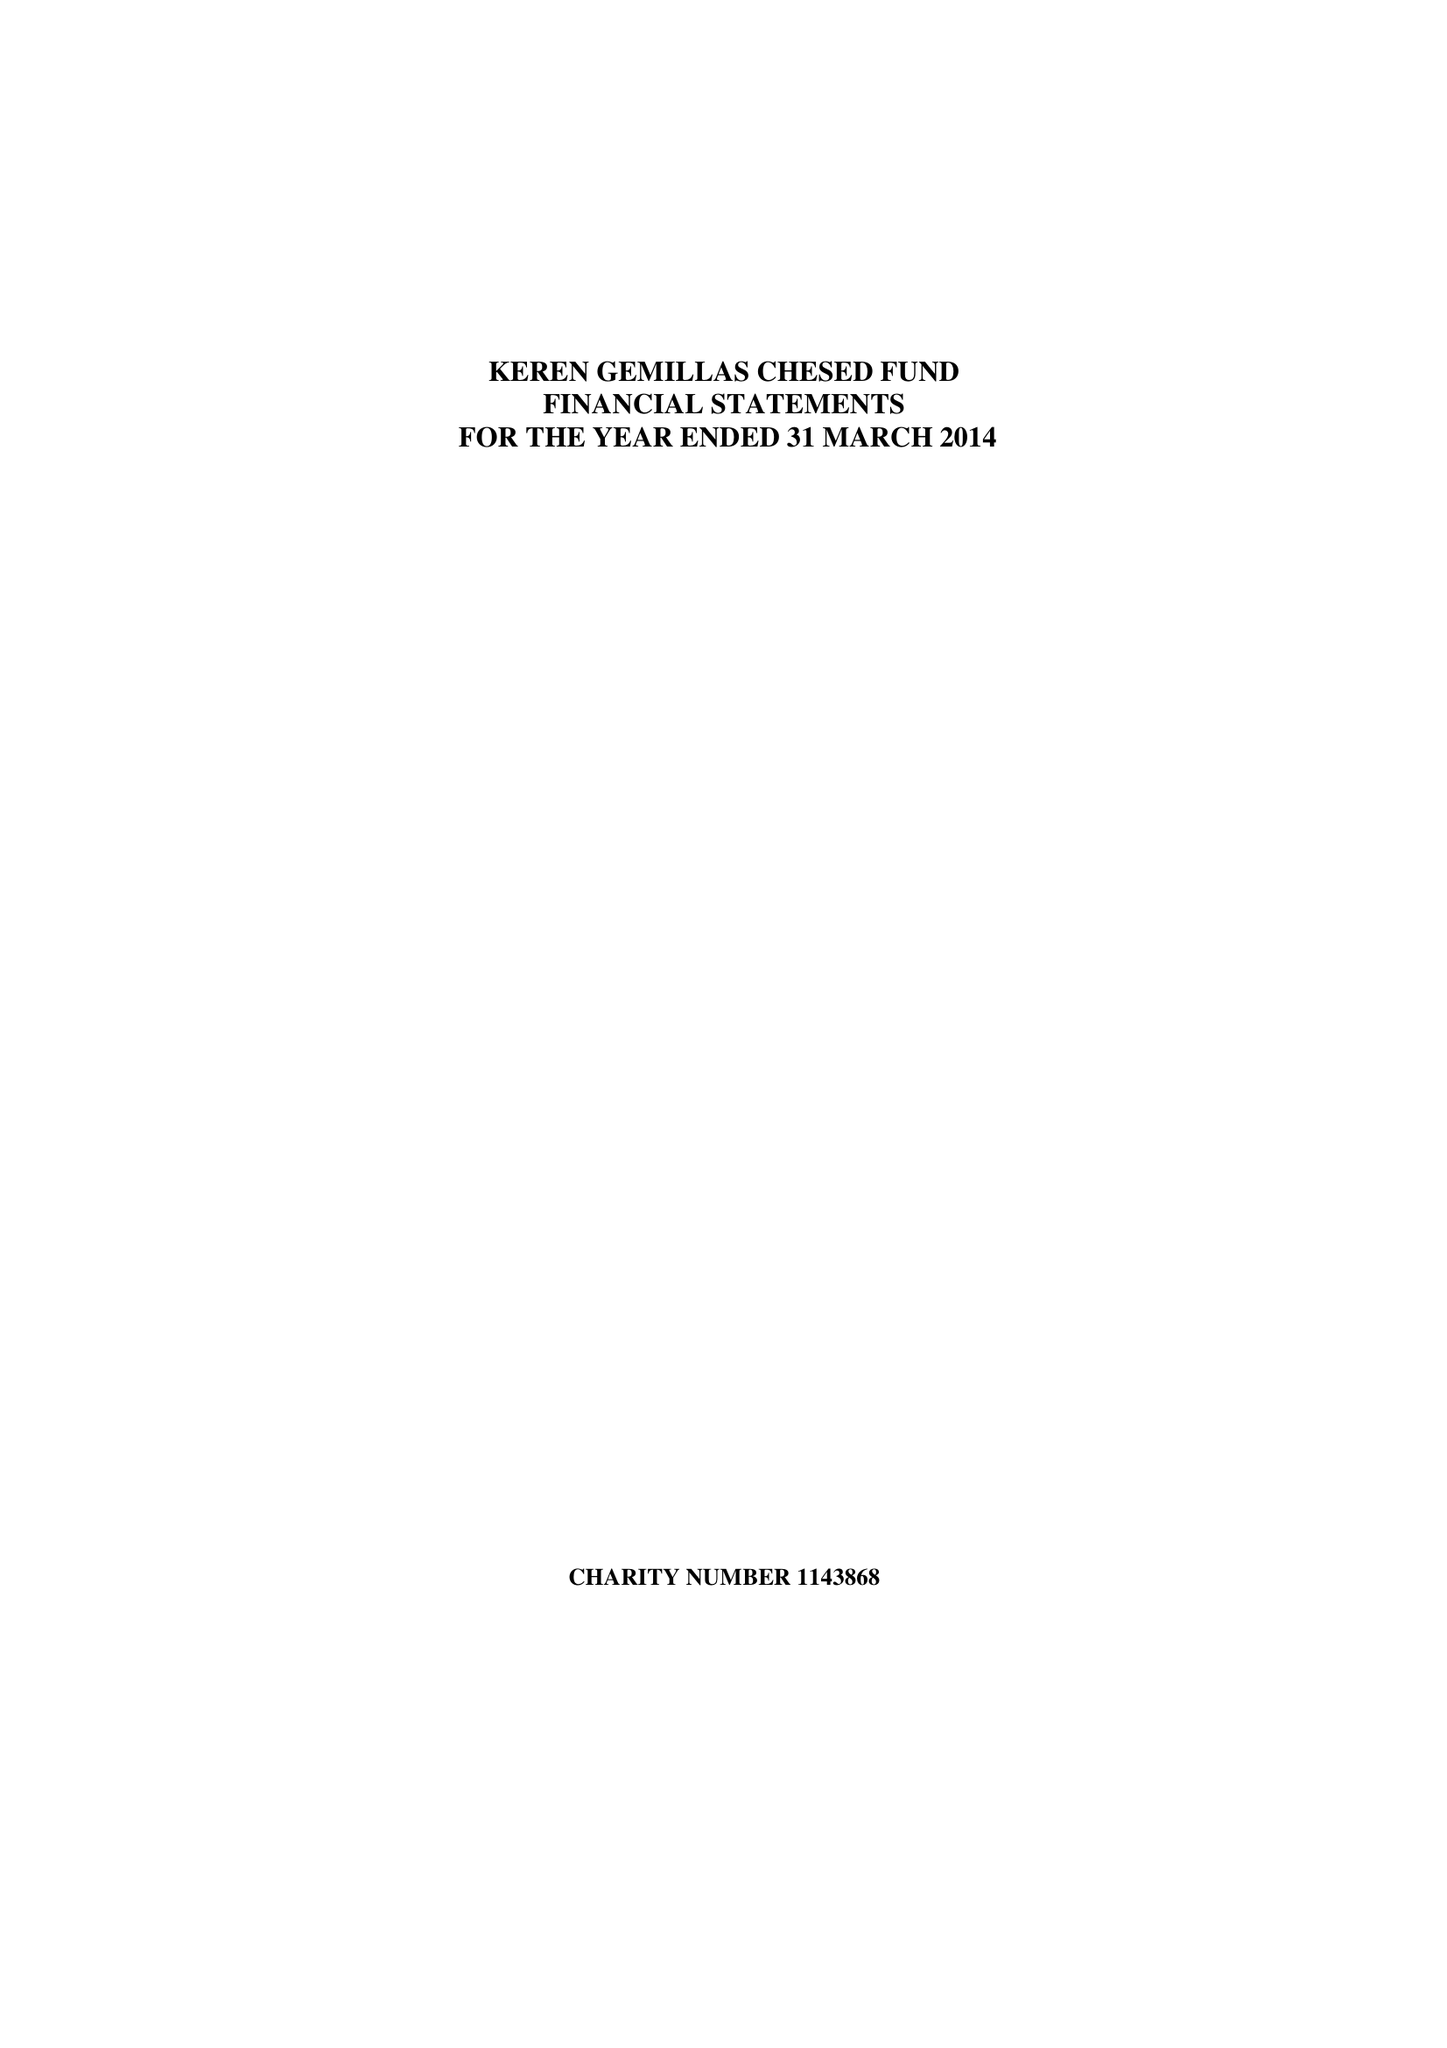What is the value for the report_date?
Answer the question using a single word or phrase. 2014-03-31 